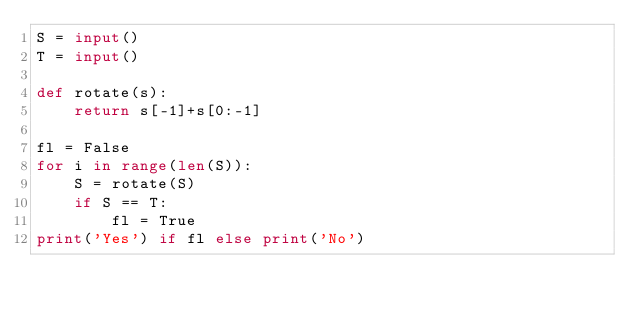<code> <loc_0><loc_0><loc_500><loc_500><_Python_>S = input()
T = input()

def rotate(s):
    return s[-1]+s[0:-1]

fl = False
for i in range(len(S)):
    S = rotate(S)
    if S == T:
        fl = True
print('Yes') if fl else print('No')</code> 